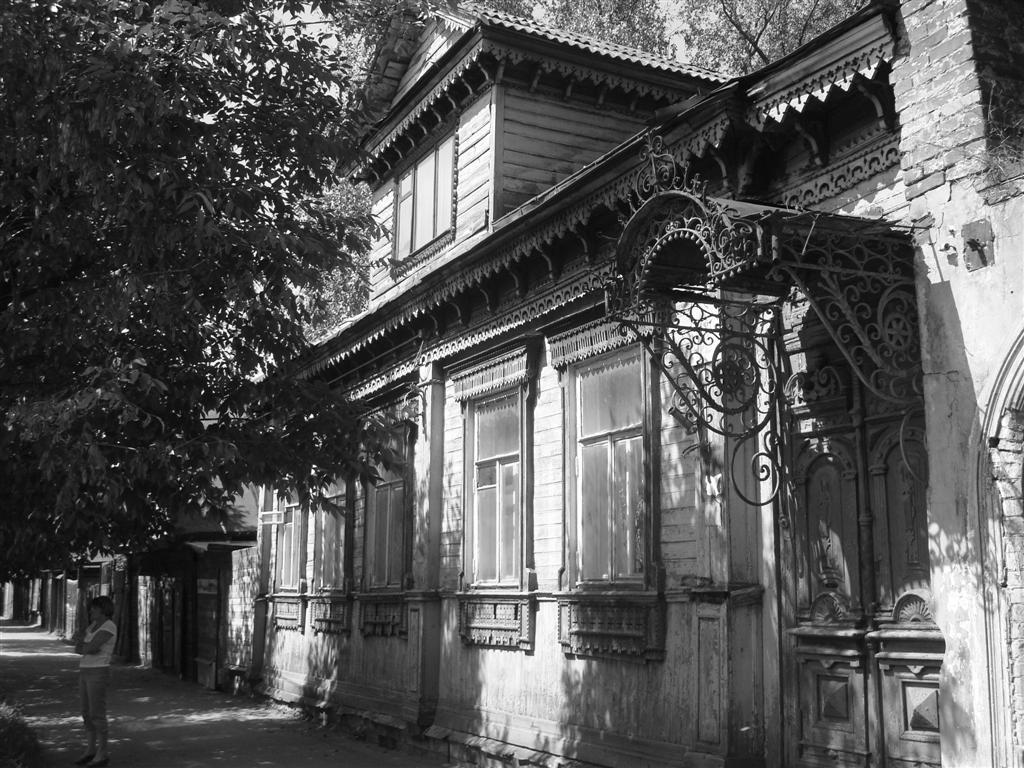Who is the main subject in the image? There is a girl in the image. Where is the girl located? The girl is on the road. What can be seen on the right side of the image? There is a building on the right side of the image. What is on the left side of the image? There is a tree on the left side of the image. How many fingers can be seen on the girl's hand in the image? There is no visible hand or fingers of the girl in the image. Is the girl taking a bath in the image? There is no indication of a bath or any water-related activity in the image. 